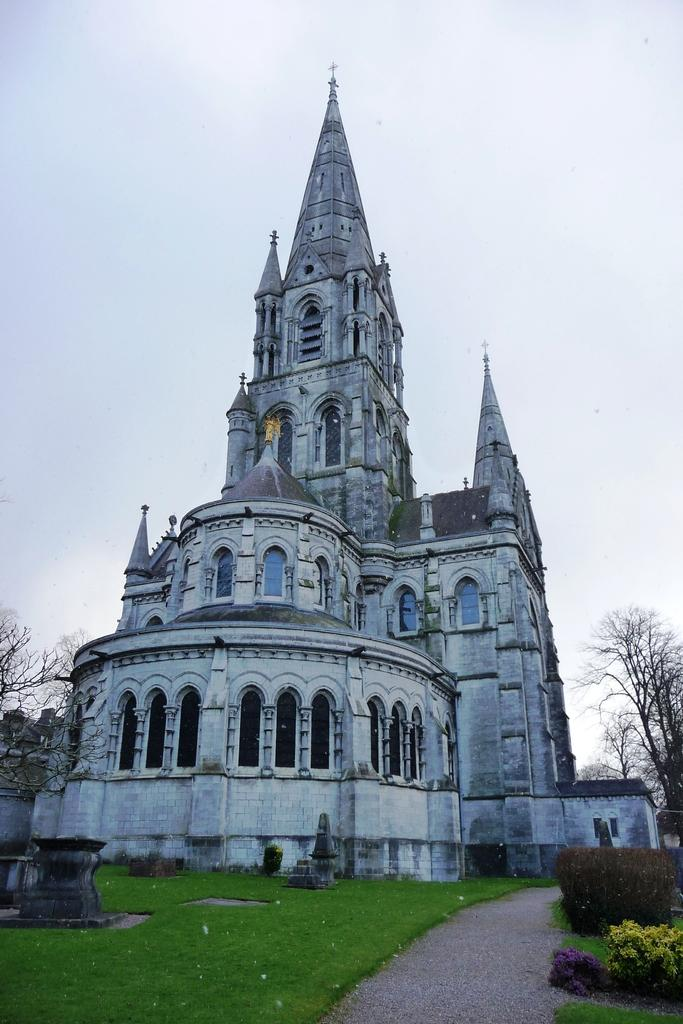What is the color of the building in the image? The building in the image is white in color. What can be seen on the left side of the image? There are dried trees on the left side of the image. What can be seen on the right side of the image? There are dried trees on the right side of the image. What type of trees have a green color in the image? There are trees with green color in the image. What type of vegetation has a green color in the image? There is grass with green color in the image. What is the color of the sky at the top of the image? The sky is white in color at the top of the image. What type of government is depicted in the image? There is no depiction of a government in the image; it features a white building, trees, grass, and a white sky. Can you tell me how many frogs are present in the image? There are no frogs present in the image. 